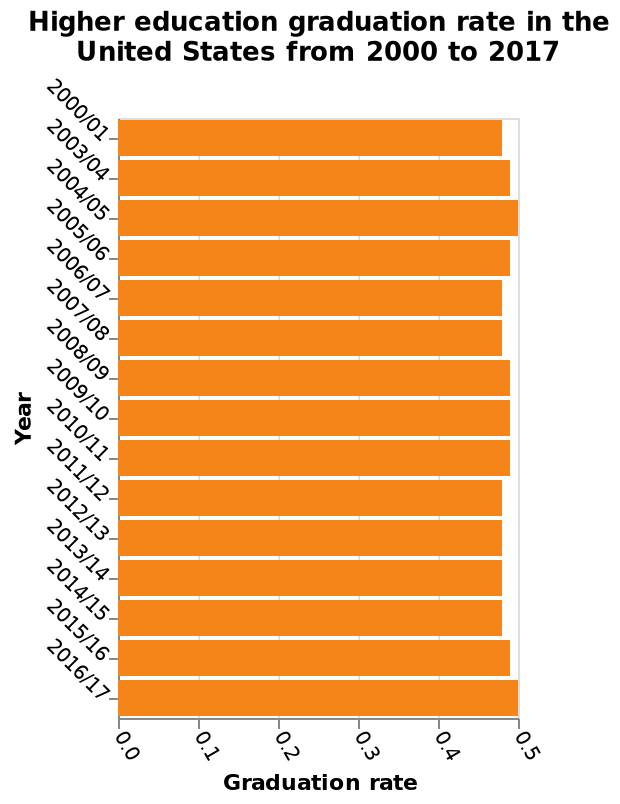<image>
What type of graph represents the higher education graduation rate in the United States from 2000 to 2017? A bar graph represents the higher education graduation rate in the United States from 2000 to 2017. During which time period did the graduation rates experience a decline? The graduation rates experienced a decline between 2011 and 2015. What is plotted on the x-axis of the graph? The graduation rate is plotted on the x-axis of the graph. 